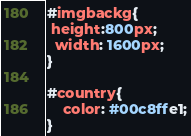<code> <loc_0><loc_0><loc_500><loc_500><_CSS_>#imgbackg{
 height:800px;
  width: 1600px;
}

#country{
    color: #00c8ffe1;
}</code> 